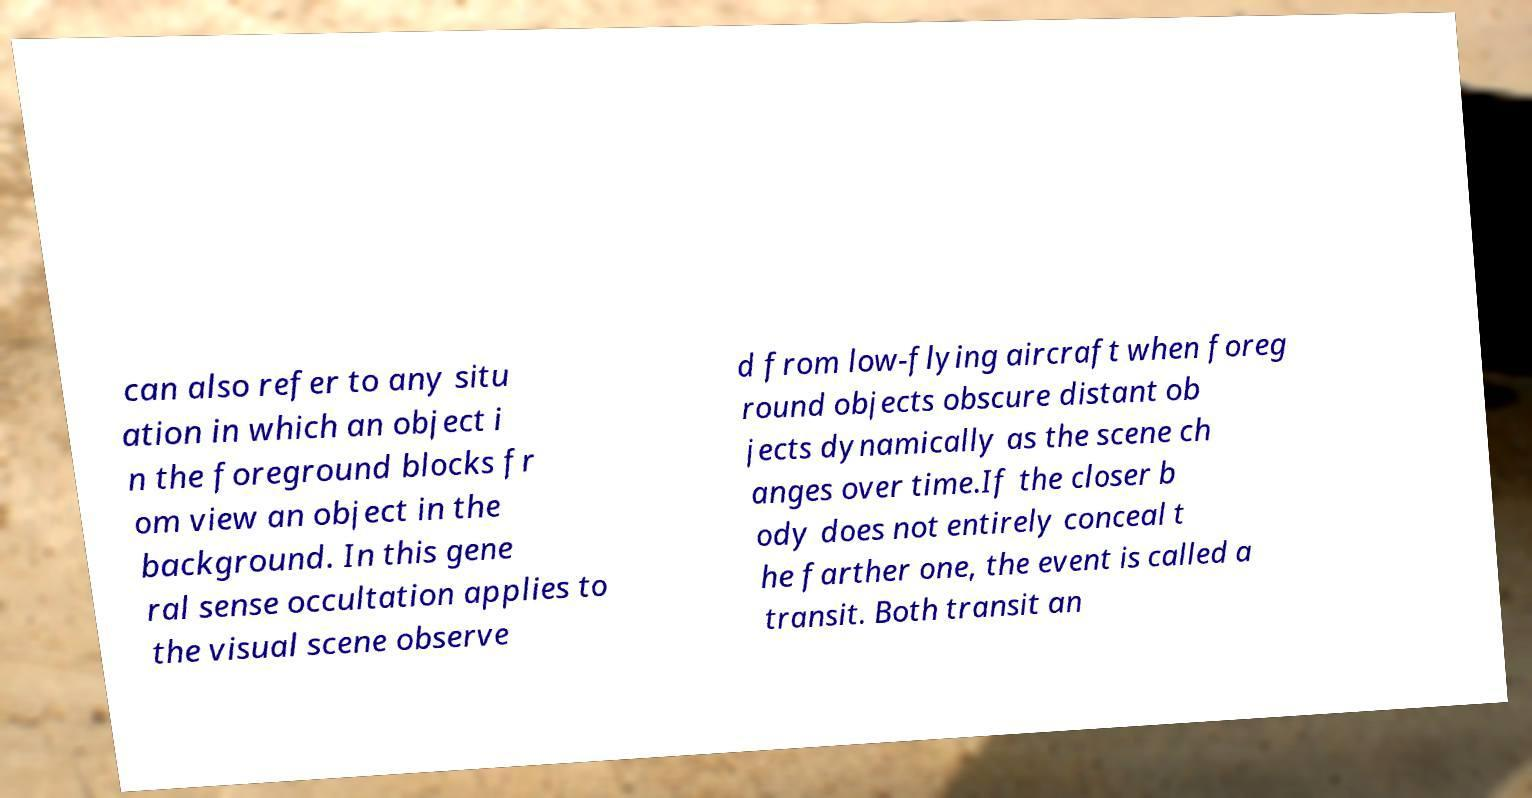Can you accurately transcribe the text from the provided image for me? can also refer to any situ ation in which an object i n the foreground blocks fr om view an object in the background. In this gene ral sense occultation applies to the visual scene observe d from low-flying aircraft when foreg round objects obscure distant ob jects dynamically as the scene ch anges over time.If the closer b ody does not entirely conceal t he farther one, the event is called a transit. Both transit an 